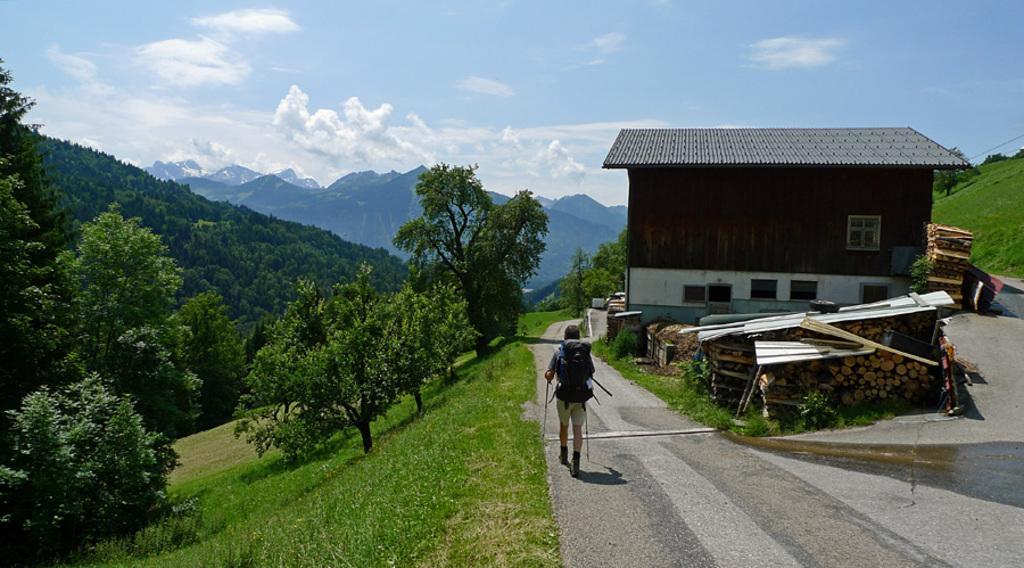Please provide a concise description of this image. This is an outside view. At the bottom a person is wearing a bag and walking on the road towards the back side. On the right side there is a house. In front of this house there are many trunks and also I can see the grass on the ground. On the left side there are many trees and mountains. At the top of the image I can see the sky and clouds. 